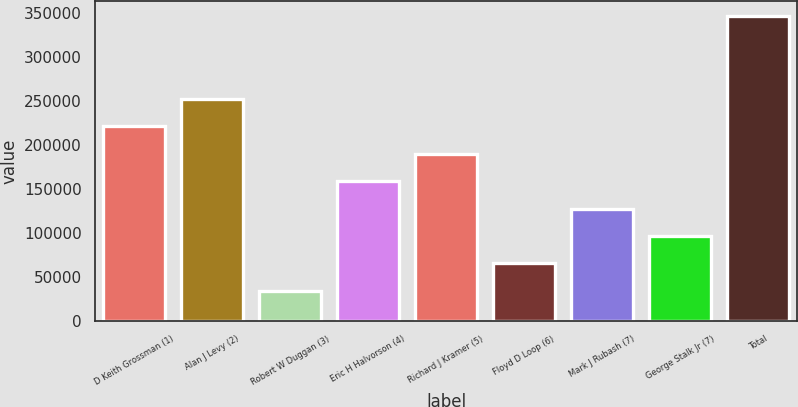Convert chart. <chart><loc_0><loc_0><loc_500><loc_500><bar_chart><fcel>D Keith Grossman (1)<fcel>Alan J Levy (2)<fcel>Robert W Duggan (3)<fcel>Eric H Halvorson (4)<fcel>Richard J Kramer (5)<fcel>Floyd D Loop (6)<fcel>Mark J Rubash (7)<fcel>George Stalk Jr (7)<fcel>Total<nl><fcel>221450<fcel>252650<fcel>34250<fcel>159050<fcel>190250<fcel>65450<fcel>127850<fcel>96650<fcel>346250<nl></chart> 